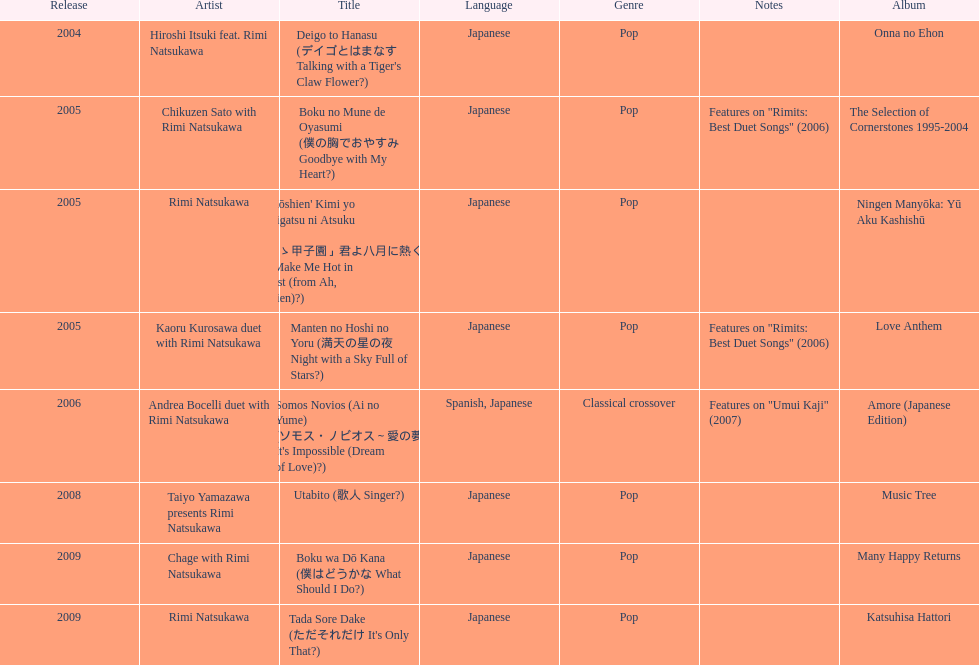Which title has the same notes as night with a sky full of stars? Boku no Mune de Oyasumi (僕の胸でおやすみ Goodbye with My Heart?). 